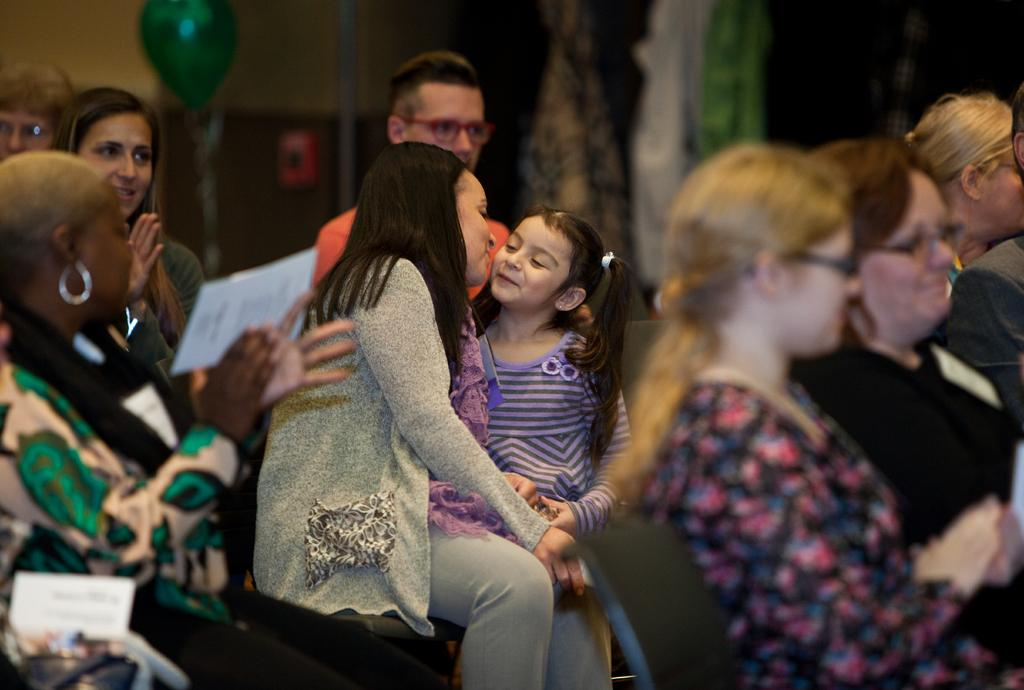How many people are in the image? There are a few people in the image. What can be seen on the wall in the image? There is a wall with some objects in the image. What type of object is present in the image that is typically associated with celebrations or parties? There is a balloon in the image. Where is the toad located in the image? There is no toad present in the image. What type of market is depicted in the image? There is no market present in the image. 